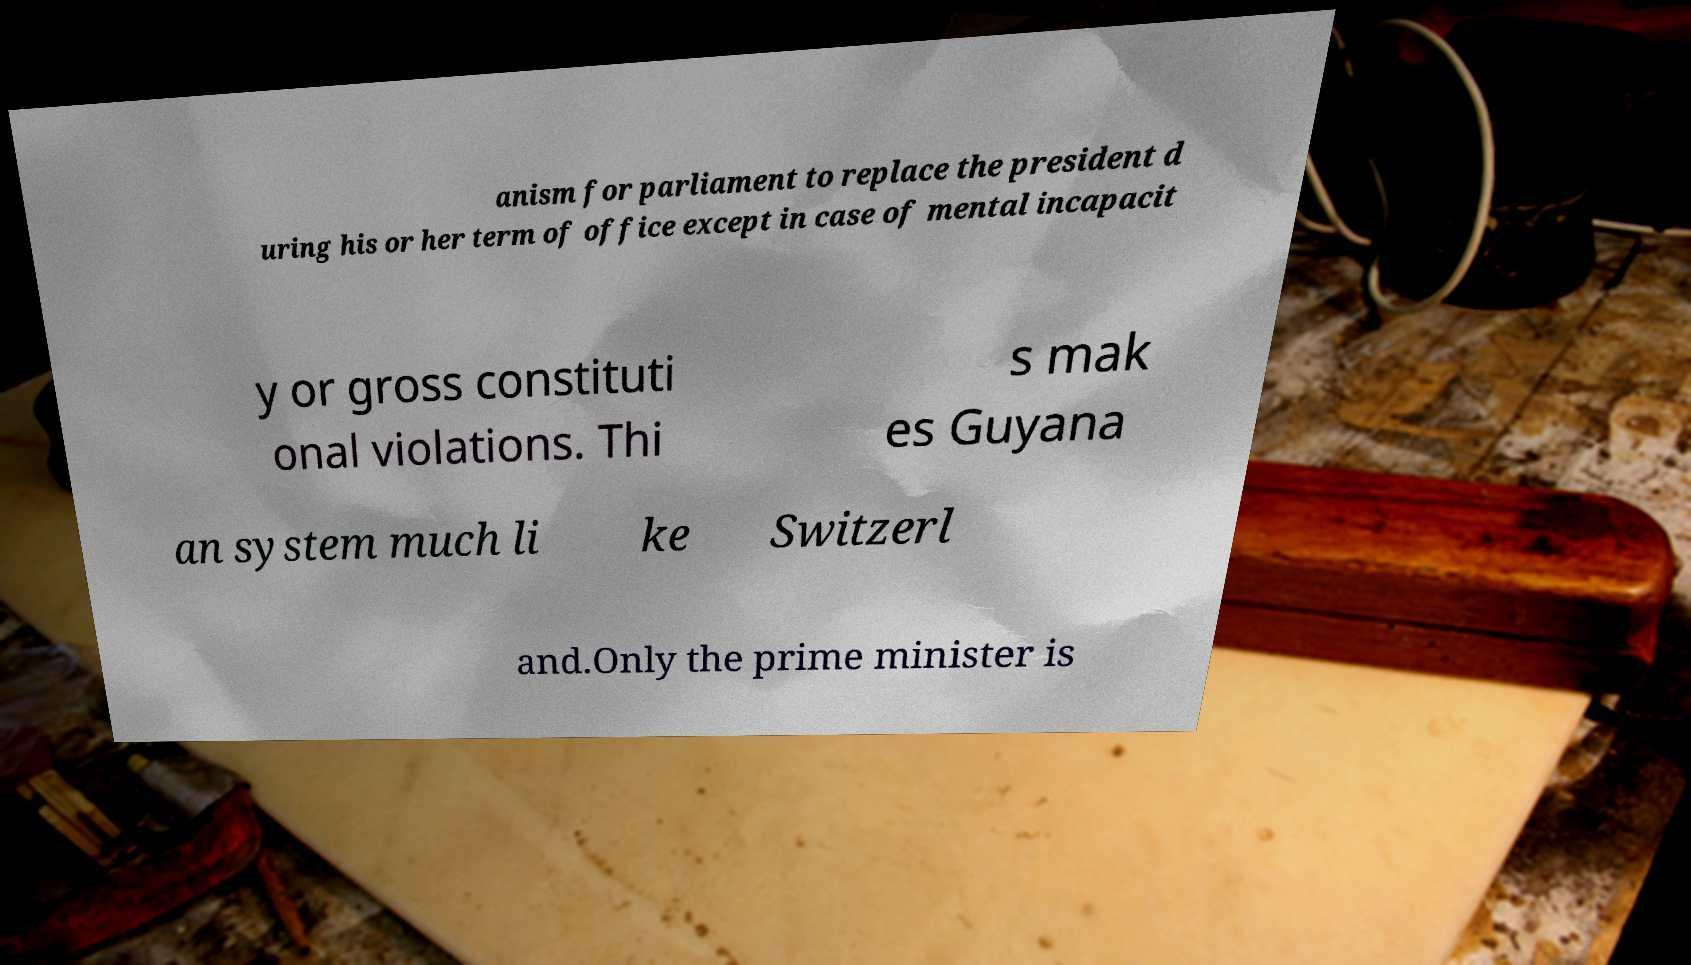Please read and relay the text visible in this image. What does it say? anism for parliament to replace the president d uring his or her term of office except in case of mental incapacit y or gross constituti onal violations. Thi s mak es Guyana an system much li ke Switzerl and.Only the prime minister is 